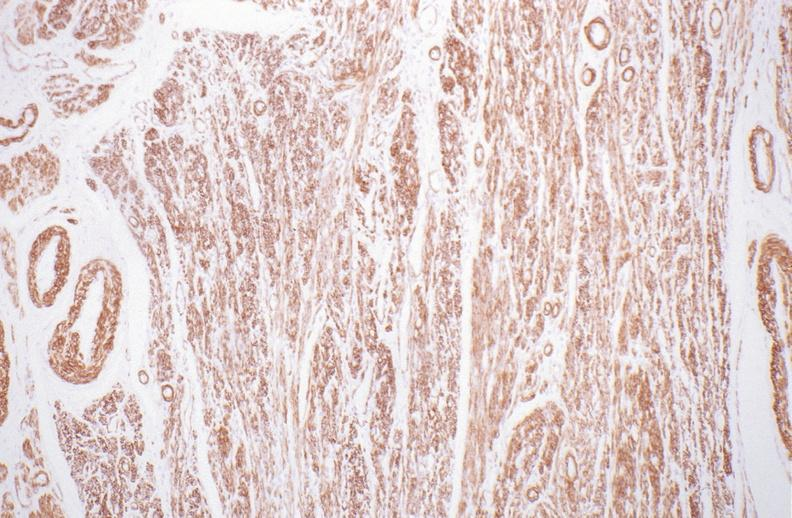what stain?
Answer the question using a single word or phrase. Alpha smooth muscle actin immunohistochemical 